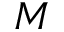<formula> <loc_0><loc_0><loc_500><loc_500>M</formula> 